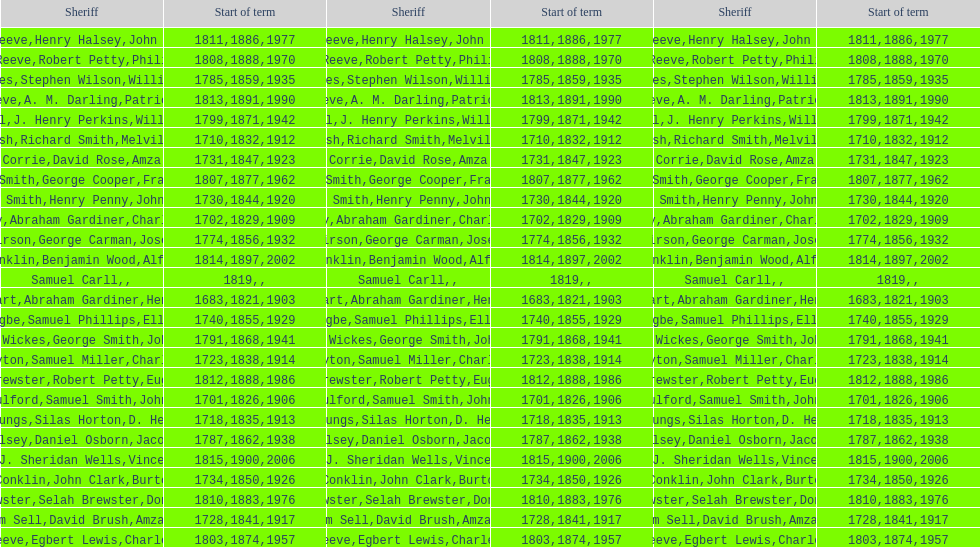Did robert petty serve before josiah reeve? No. 